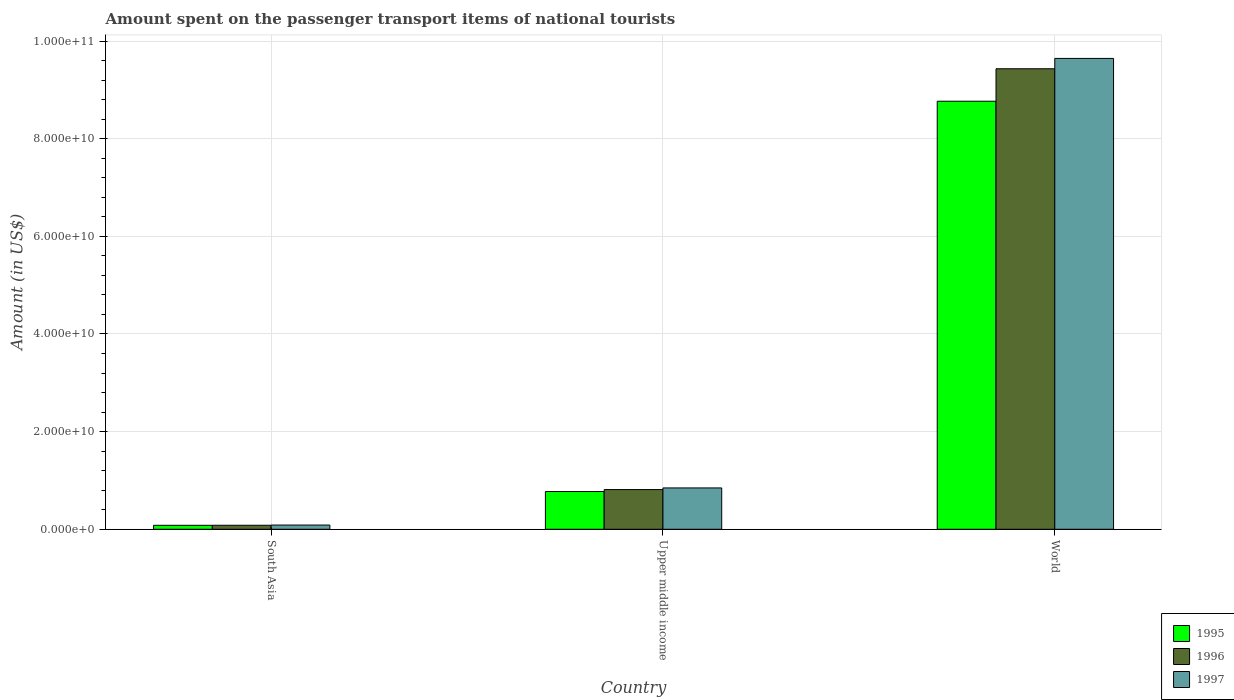How many different coloured bars are there?
Ensure brevity in your answer.  3. How many groups of bars are there?
Your response must be concise. 3. Are the number of bars on each tick of the X-axis equal?
Give a very brief answer. Yes. How many bars are there on the 1st tick from the right?
Make the answer very short. 3. What is the label of the 1st group of bars from the left?
Give a very brief answer. South Asia. What is the amount spent on the passenger transport items of national tourists in 1996 in South Asia?
Ensure brevity in your answer.  8.23e+08. Across all countries, what is the maximum amount spent on the passenger transport items of national tourists in 1996?
Your answer should be compact. 9.43e+1. Across all countries, what is the minimum amount spent on the passenger transport items of national tourists in 1996?
Give a very brief answer. 8.23e+08. In which country was the amount spent on the passenger transport items of national tourists in 1995 maximum?
Your response must be concise. World. In which country was the amount spent on the passenger transport items of national tourists in 1995 minimum?
Offer a very short reply. South Asia. What is the total amount spent on the passenger transport items of national tourists in 1997 in the graph?
Make the answer very short. 1.06e+11. What is the difference between the amount spent on the passenger transport items of national tourists in 1996 in South Asia and that in World?
Keep it short and to the point. -9.35e+1. What is the difference between the amount spent on the passenger transport items of national tourists in 1997 in Upper middle income and the amount spent on the passenger transport items of national tourists in 1996 in World?
Provide a short and direct response. -8.59e+1. What is the average amount spent on the passenger transport items of national tourists in 1995 per country?
Your answer should be compact. 3.21e+1. What is the difference between the amount spent on the passenger transport items of national tourists of/in 1996 and amount spent on the passenger transport items of national tourists of/in 1995 in Upper middle income?
Keep it short and to the point. 3.97e+08. In how many countries, is the amount spent on the passenger transport items of national tourists in 1997 greater than 48000000000 US$?
Keep it short and to the point. 1. What is the ratio of the amount spent on the passenger transport items of national tourists in 1996 in South Asia to that in World?
Your answer should be very brief. 0.01. Is the difference between the amount spent on the passenger transport items of national tourists in 1996 in Upper middle income and World greater than the difference between the amount spent on the passenger transport items of national tourists in 1995 in Upper middle income and World?
Offer a terse response. No. What is the difference between the highest and the second highest amount spent on the passenger transport items of national tourists in 1997?
Offer a terse response. -7.60e+09. What is the difference between the highest and the lowest amount spent on the passenger transport items of national tourists in 1997?
Provide a succinct answer. 9.56e+1. Is the sum of the amount spent on the passenger transport items of national tourists in 1995 in South Asia and World greater than the maximum amount spent on the passenger transport items of national tourists in 1996 across all countries?
Your response must be concise. No. What does the 3rd bar from the left in South Asia represents?
Keep it short and to the point. 1997. Is it the case that in every country, the sum of the amount spent on the passenger transport items of national tourists in 1997 and amount spent on the passenger transport items of national tourists in 1996 is greater than the amount spent on the passenger transport items of national tourists in 1995?
Your response must be concise. Yes. How many bars are there?
Offer a very short reply. 9. Are all the bars in the graph horizontal?
Keep it short and to the point. No. How many countries are there in the graph?
Ensure brevity in your answer.  3. Does the graph contain grids?
Offer a terse response. Yes. How many legend labels are there?
Offer a very short reply. 3. How are the legend labels stacked?
Offer a very short reply. Vertical. What is the title of the graph?
Your response must be concise. Amount spent on the passenger transport items of national tourists. What is the label or title of the X-axis?
Your response must be concise. Country. What is the label or title of the Y-axis?
Your answer should be very brief. Amount (in US$). What is the Amount (in US$) of 1995 in South Asia?
Offer a very short reply. 8.12e+08. What is the Amount (in US$) in 1996 in South Asia?
Offer a terse response. 8.23e+08. What is the Amount (in US$) of 1997 in South Asia?
Offer a very short reply. 8.66e+08. What is the Amount (in US$) in 1995 in Upper middle income?
Ensure brevity in your answer.  7.73e+09. What is the Amount (in US$) of 1996 in Upper middle income?
Ensure brevity in your answer.  8.13e+09. What is the Amount (in US$) in 1997 in Upper middle income?
Provide a short and direct response. 8.47e+09. What is the Amount (in US$) in 1995 in World?
Give a very brief answer. 8.77e+1. What is the Amount (in US$) in 1996 in World?
Provide a short and direct response. 9.43e+1. What is the Amount (in US$) in 1997 in World?
Provide a succinct answer. 9.64e+1. Across all countries, what is the maximum Amount (in US$) of 1995?
Make the answer very short. 8.77e+1. Across all countries, what is the maximum Amount (in US$) of 1996?
Make the answer very short. 9.43e+1. Across all countries, what is the maximum Amount (in US$) of 1997?
Offer a terse response. 9.64e+1. Across all countries, what is the minimum Amount (in US$) in 1995?
Give a very brief answer. 8.12e+08. Across all countries, what is the minimum Amount (in US$) of 1996?
Your answer should be compact. 8.23e+08. Across all countries, what is the minimum Amount (in US$) of 1997?
Keep it short and to the point. 8.66e+08. What is the total Amount (in US$) in 1995 in the graph?
Keep it short and to the point. 9.62e+1. What is the total Amount (in US$) of 1996 in the graph?
Keep it short and to the point. 1.03e+11. What is the total Amount (in US$) in 1997 in the graph?
Provide a succinct answer. 1.06e+11. What is the difference between the Amount (in US$) in 1995 in South Asia and that in Upper middle income?
Make the answer very short. -6.92e+09. What is the difference between the Amount (in US$) in 1996 in South Asia and that in Upper middle income?
Provide a succinct answer. -7.31e+09. What is the difference between the Amount (in US$) of 1997 in South Asia and that in Upper middle income?
Ensure brevity in your answer.  -7.60e+09. What is the difference between the Amount (in US$) of 1995 in South Asia and that in World?
Make the answer very short. -8.69e+1. What is the difference between the Amount (in US$) of 1996 in South Asia and that in World?
Offer a terse response. -9.35e+1. What is the difference between the Amount (in US$) of 1997 in South Asia and that in World?
Provide a succinct answer. -9.56e+1. What is the difference between the Amount (in US$) in 1995 in Upper middle income and that in World?
Ensure brevity in your answer.  -7.99e+1. What is the difference between the Amount (in US$) of 1996 in Upper middle income and that in World?
Your answer should be very brief. -8.62e+1. What is the difference between the Amount (in US$) of 1997 in Upper middle income and that in World?
Ensure brevity in your answer.  -8.80e+1. What is the difference between the Amount (in US$) in 1995 in South Asia and the Amount (in US$) in 1996 in Upper middle income?
Provide a succinct answer. -7.32e+09. What is the difference between the Amount (in US$) of 1995 in South Asia and the Amount (in US$) of 1997 in Upper middle income?
Your answer should be very brief. -7.66e+09. What is the difference between the Amount (in US$) in 1996 in South Asia and the Amount (in US$) in 1997 in Upper middle income?
Your answer should be very brief. -7.65e+09. What is the difference between the Amount (in US$) of 1995 in South Asia and the Amount (in US$) of 1996 in World?
Keep it short and to the point. -9.35e+1. What is the difference between the Amount (in US$) in 1995 in South Asia and the Amount (in US$) in 1997 in World?
Offer a terse response. -9.56e+1. What is the difference between the Amount (in US$) of 1996 in South Asia and the Amount (in US$) of 1997 in World?
Keep it short and to the point. -9.56e+1. What is the difference between the Amount (in US$) of 1995 in Upper middle income and the Amount (in US$) of 1996 in World?
Your answer should be compact. -8.66e+1. What is the difference between the Amount (in US$) in 1995 in Upper middle income and the Amount (in US$) in 1997 in World?
Provide a short and direct response. -8.87e+1. What is the difference between the Amount (in US$) of 1996 in Upper middle income and the Amount (in US$) of 1997 in World?
Ensure brevity in your answer.  -8.83e+1. What is the average Amount (in US$) of 1995 per country?
Offer a very short reply. 3.21e+1. What is the average Amount (in US$) in 1996 per country?
Provide a succinct answer. 3.44e+1. What is the average Amount (in US$) of 1997 per country?
Ensure brevity in your answer.  3.53e+1. What is the difference between the Amount (in US$) in 1995 and Amount (in US$) in 1996 in South Asia?
Offer a very short reply. -1.09e+07. What is the difference between the Amount (in US$) in 1995 and Amount (in US$) in 1997 in South Asia?
Provide a short and direct response. -5.35e+07. What is the difference between the Amount (in US$) in 1996 and Amount (in US$) in 1997 in South Asia?
Make the answer very short. -4.25e+07. What is the difference between the Amount (in US$) of 1995 and Amount (in US$) of 1996 in Upper middle income?
Make the answer very short. -3.97e+08. What is the difference between the Amount (in US$) in 1995 and Amount (in US$) in 1997 in Upper middle income?
Your answer should be compact. -7.36e+08. What is the difference between the Amount (in US$) of 1996 and Amount (in US$) of 1997 in Upper middle income?
Offer a very short reply. -3.39e+08. What is the difference between the Amount (in US$) in 1995 and Amount (in US$) in 1996 in World?
Your response must be concise. -6.65e+09. What is the difference between the Amount (in US$) of 1995 and Amount (in US$) of 1997 in World?
Give a very brief answer. -8.77e+09. What is the difference between the Amount (in US$) in 1996 and Amount (in US$) in 1997 in World?
Make the answer very short. -2.12e+09. What is the ratio of the Amount (in US$) in 1995 in South Asia to that in Upper middle income?
Offer a very short reply. 0.1. What is the ratio of the Amount (in US$) of 1996 in South Asia to that in Upper middle income?
Make the answer very short. 0.1. What is the ratio of the Amount (in US$) of 1997 in South Asia to that in Upper middle income?
Your answer should be very brief. 0.1. What is the ratio of the Amount (in US$) in 1995 in South Asia to that in World?
Provide a short and direct response. 0.01. What is the ratio of the Amount (in US$) of 1996 in South Asia to that in World?
Ensure brevity in your answer.  0.01. What is the ratio of the Amount (in US$) of 1997 in South Asia to that in World?
Your answer should be very brief. 0.01. What is the ratio of the Amount (in US$) of 1995 in Upper middle income to that in World?
Your answer should be compact. 0.09. What is the ratio of the Amount (in US$) in 1996 in Upper middle income to that in World?
Give a very brief answer. 0.09. What is the ratio of the Amount (in US$) in 1997 in Upper middle income to that in World?
Give a very brief answer. 0.09. What is the difference between the highest and the second highest Amount (in US$) in 1995?
Your response must be concise. 7.99e+1. What is the difference between the highest and the second highest Amount (in US$) in 1996?
Your answer should be compact. 8.62e+1. What is the difference between the highest and the second highest Amount (in US$) of 1997?
Your answer should be very brief. 8.80e+1. What is the difference between the highest and the lowest Amount (in US$) of 1995?
Ensure brevity in your answer.  8.69e+1. What is the difference between the highest and the lowest Amount (in US$) in 1996?
Your answer should be compact. 9.35e+1. What is the difference between the highest and the lowest Amount (in US$) of 1997?
Make the answer very short. 9.56e+1. 